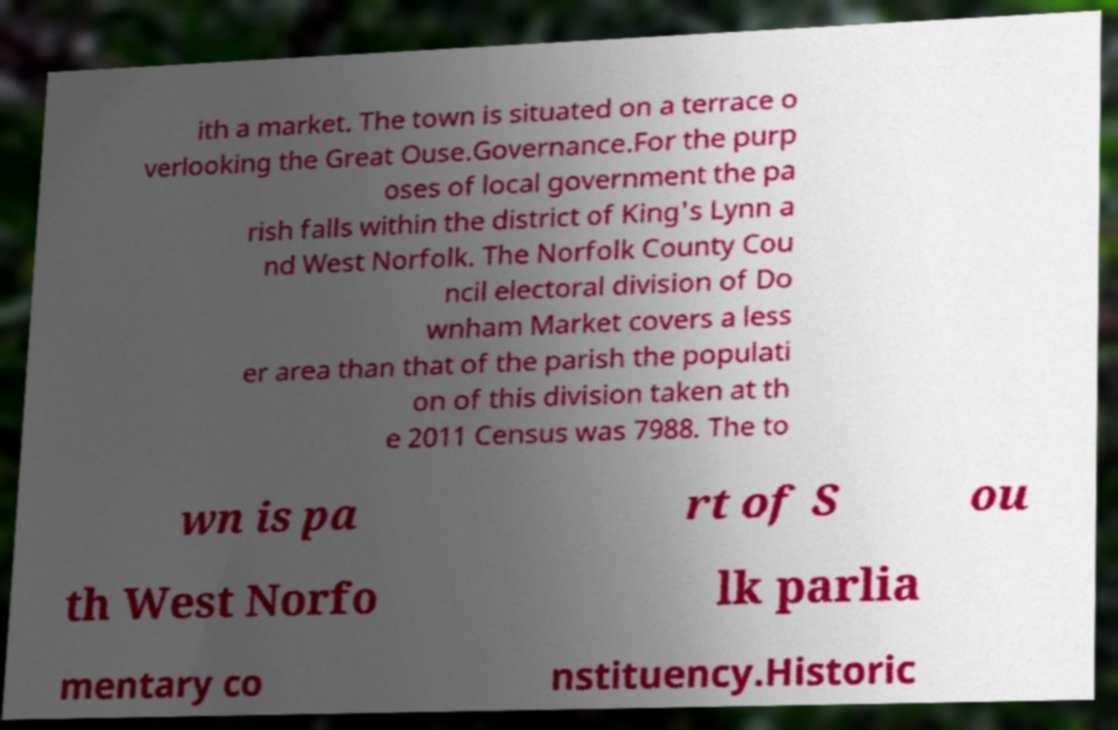Could you assist in decoding the text presented in this image and type it out clearly? ith a market. The town is situated on a terrace o verlooking the Great Ouse.Governance.For the purp oses of local government the pa rish falls within the district of King's Lynn a nd West Norfolk. The Norfolk County Cou ncil electoral division of Do wnham Market covers a less er area than that of the parish the populati on of this division taken at th e 2011 Census was 7988. The to wn is pa rt of S ou th West Norfo lk parlia mentary co nstituency.Historic 